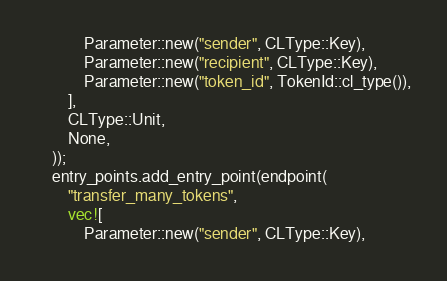Convert code to text. <code><loc_0><loc_0><loc_500><loc_500><_Rust_>            Parameter::new("sender", CLType::Key),
            Parameter::new("recipient", CLType::Key),
            Parameter::new("token_id", TokenId::cl_type()),
        ],
        CLType::Unit,
        None,
    ));
    entry_points.add_entry_point(endpoint(
        "transfer_many_tokens",
        vec![
            Parameter::new("sender", CLType::Key),</code> 